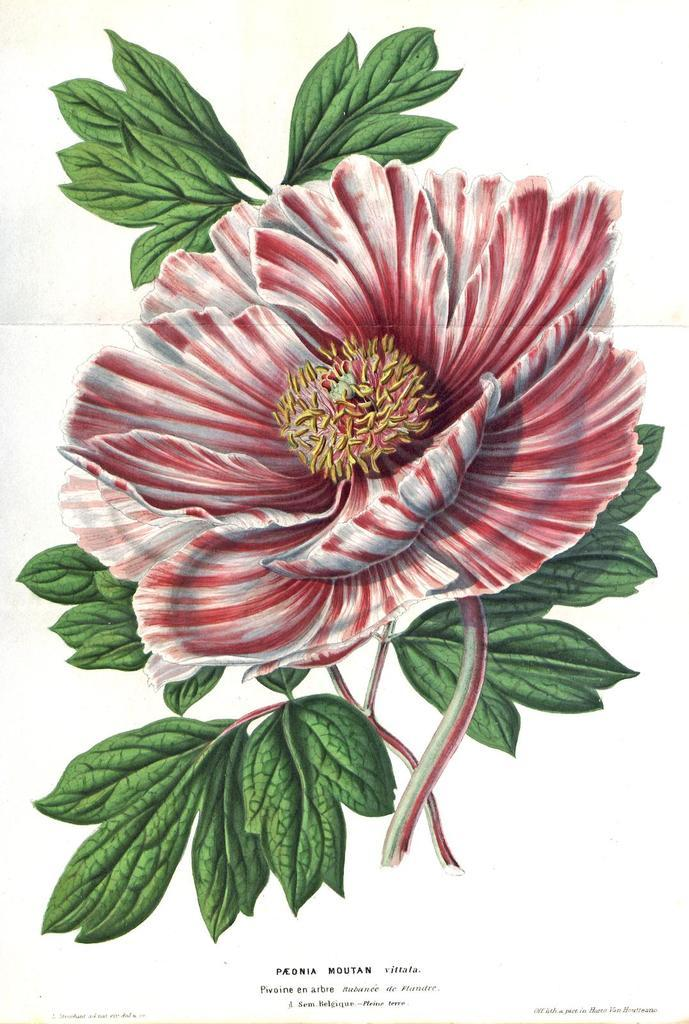What is featured on the poster in the image? The poster contains a depiction of a flower and leaves. Are there any words on the poster? Yes, there is text on the poster. How many hands can be seen holding the frog in the image? There are no hands or frogs present in the image; it only features a poster with a depiction of a flower and leaves, along with text. 